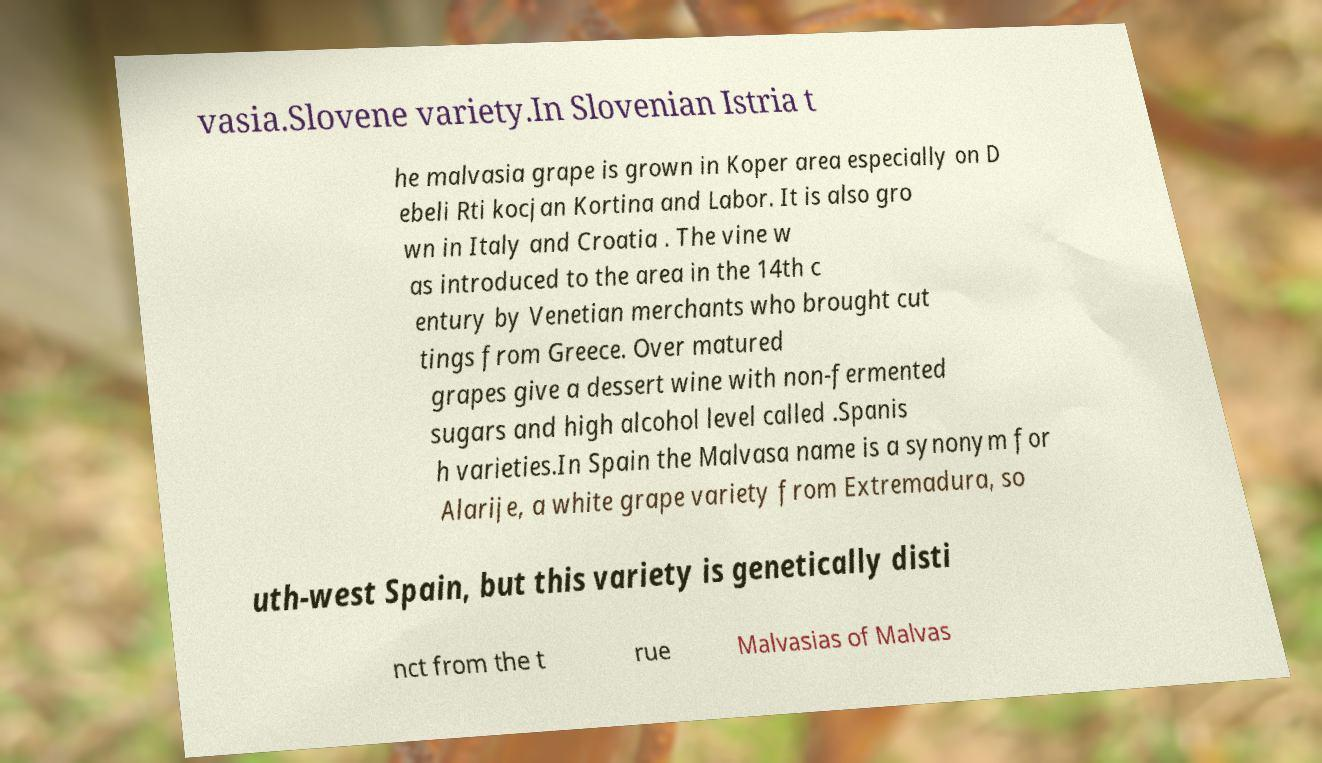Could you extract and type out the text from this image? vasia.Slovene variety.In Slovenian Istria t he malvasia grape is grown in Koper area especially on D ebeli Rti kocjan Kortina and Labor. It is also gro wn in Italy and Croatia . The vine w as introduced to the area in the 14th c entury by Venetian merchants who brought cut tings from Greece. Over matured grapes give a dessert wine with non-fermented sugars and high alcohol level called .Spanis h varieties.In Spain the Malvasa name is a synonym for Alarije, a white grape variety from Extremadura, so uth-west Spain, but this variety is genetically disti nct from the t rue Malvasias of Malvas 